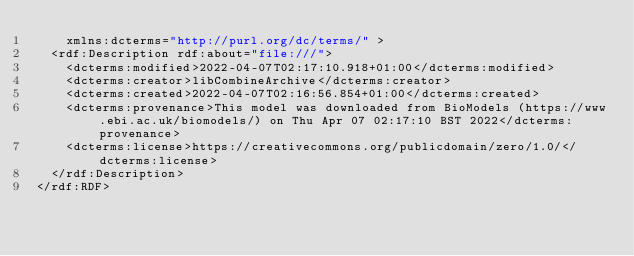<code> <loc_0><loc_0><loc_500><loc_500><_XML_>    xmlns:dcterms="http://purl.org/dc/terms/" > 
  <rdf:Description rdf:about="file:///">
    <dcterms:modified>2022-04-07T02:17:10.918+01:00</dcterms:modified>
    <dcterms:creator>libCombineArchive</dcterms:creator>
    <dcterms:created>2022-04-07T02:16:56.854+01:00</dcterms:created>
    <dcterms:provenance>This model was downloaded from BioModels (https://www.ebi.ac.uk/biomodels/) on Thu Apr 07 02:17:10 BST 2022</dcterms:provenance>
    <dcterms:license>https://creativecommons.org/publicdomain/zero/1.0/</dcterms:license>
  </rdf:Description>
</rdf:RDF>
</code> 